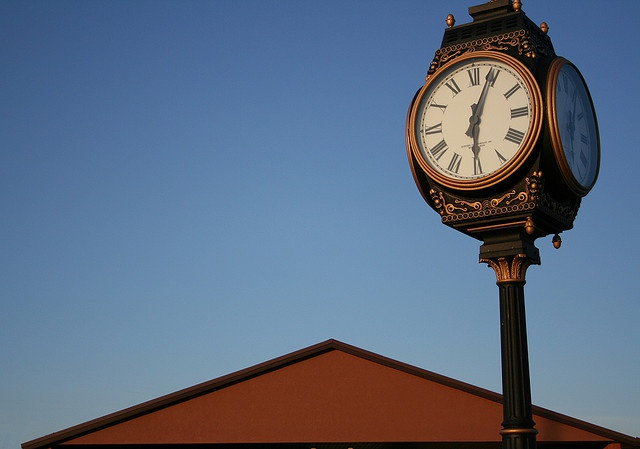Describe the objects in this image and their specific colors. I can see clock in blue, tan, gray, and black tones and clock in blue, navy, black, darkblue, and maroon tones in this image. 